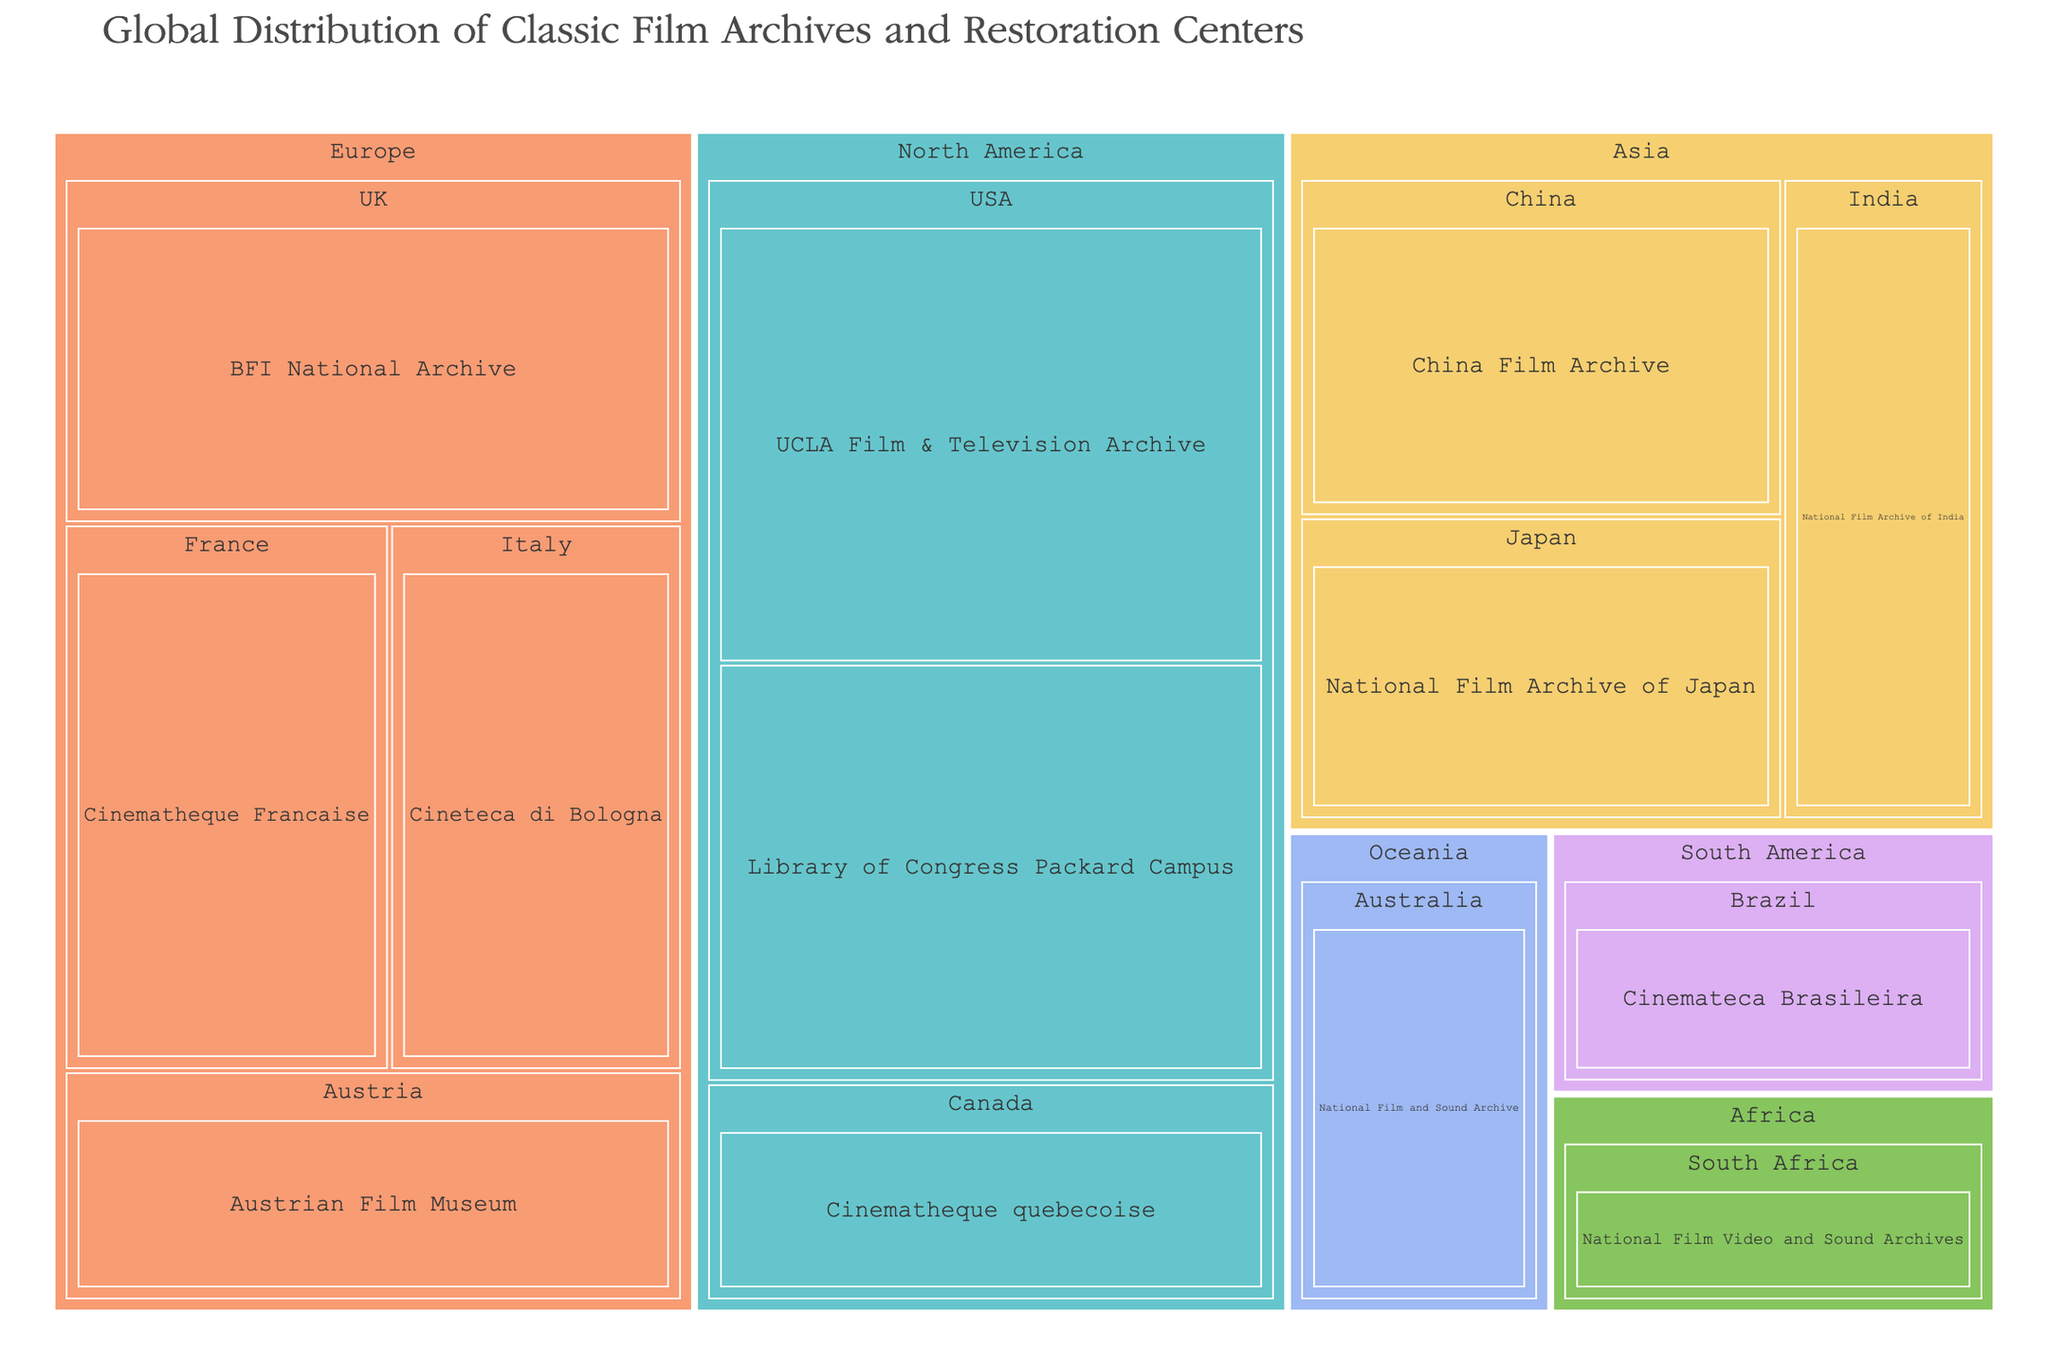What's the largest archive/center in Europe? To find the largest archive/center in Europe, look at the "Europe" section of the treemap. The center with the largest size should have the largest block. In this case, it is "BFI National Archive" in the UK with a size of 120.
Answer: BFI National Archive Which country in North America has more than one archive/center? In North America, identify the countries listed. The USA is the only country with more than one archive/center (UCLA Film & Television Archive and Library of Congress Packard Campus).
Answer: USA What is the total size of film archives and restoration centers in Asia? Sum the sizes of all archives/centers in Asia: National Film Archive of Japan (85), China Film Archive (95), and National Film Archive of India (75). So, 85 + 95 + 75 = 255.
Answer: 255 Which archive/center has the smallest size in the entire treemap? Find the smallest block in the treemap. "National Film Video and Sound Archives" in South Africa has the smallest size, which is 50.
Answer: National Film Video and Sound Archives How does the size of "Cinematheque Francaise" compare to the "National Film and Sound Archive" in Australia? Compare the sizes of "Cinematheque Francaise" (France) and "National Film and Sound Archive" (Australia). The sizes are 100 and 65, respectively. Hence, "Cinematheque Francaise" is larger.
Answer: Cinematheque Francaise is larger What's the average size of the archives/centers in Europe? Calculate the average by summing up the sizes of all European archives/centers and dividing by the number of them. (80 + 100 + 90 + 120) / 4 = 390 / 4 = 97.5
Answer: 97.5 Which region has the highest number of archives/centers listed? Count the number of archives/centers in each region: Europe (4), North America (3), Asia (3), Oceania (1), South America (1), Africa (1). Europe has the most, with 4 archives/centers.
Answer: Europe What is the difference in size between the largest and smallest centers in the treemap? The largest center is "UCLA Film & Television Archive" (150), and the smallest is "National Film Video and Sound Archives" (50). The difference is 150 - 50 = 100.
Answer: 100 